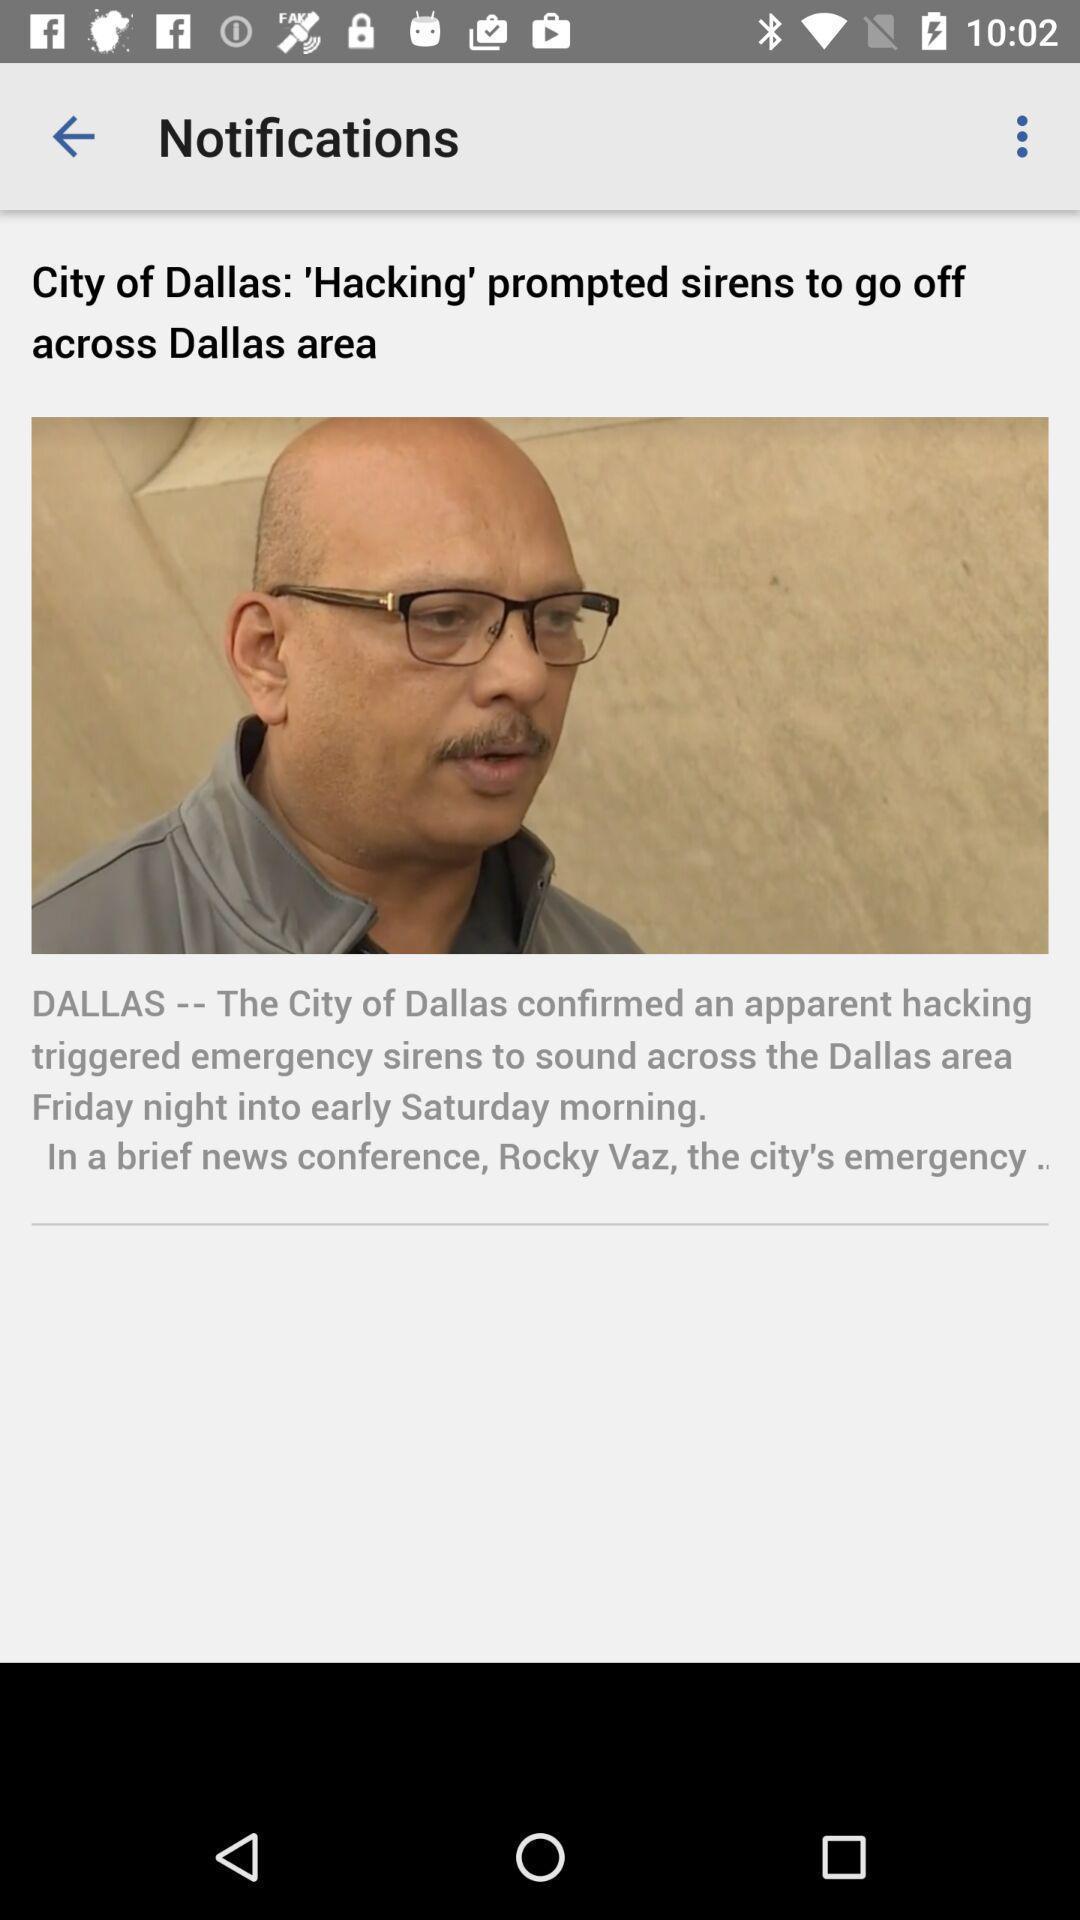Provide a description of this screenshot. Page showing latest breaking news. 